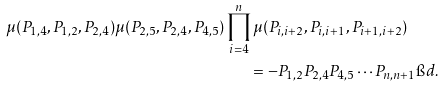Convert formula to latex. <formula><loc_0><loc_0><loc_500><loc_500>\mu ( P _ { 1 , 4 } , P _ { 1 , 2 } , P _ { 2 , 4 } ) \mu ( P _ { 2 , 5 } , P _ { 2 , 4 } , P _ { 4 , 5 } ) \prod _ { i = 4 } ^ { n } \mu ( P _ { i , i + 2 } , P _ { i , i + 1 } , P _ { i + 1 , i + 2 } ) \quad & \\ = - P _ { 1 , 2 } P _ { 2 , 4 } P _ { 4 , 5 } \cdots P _ { n , n + 1 } \i d . &</formula> 